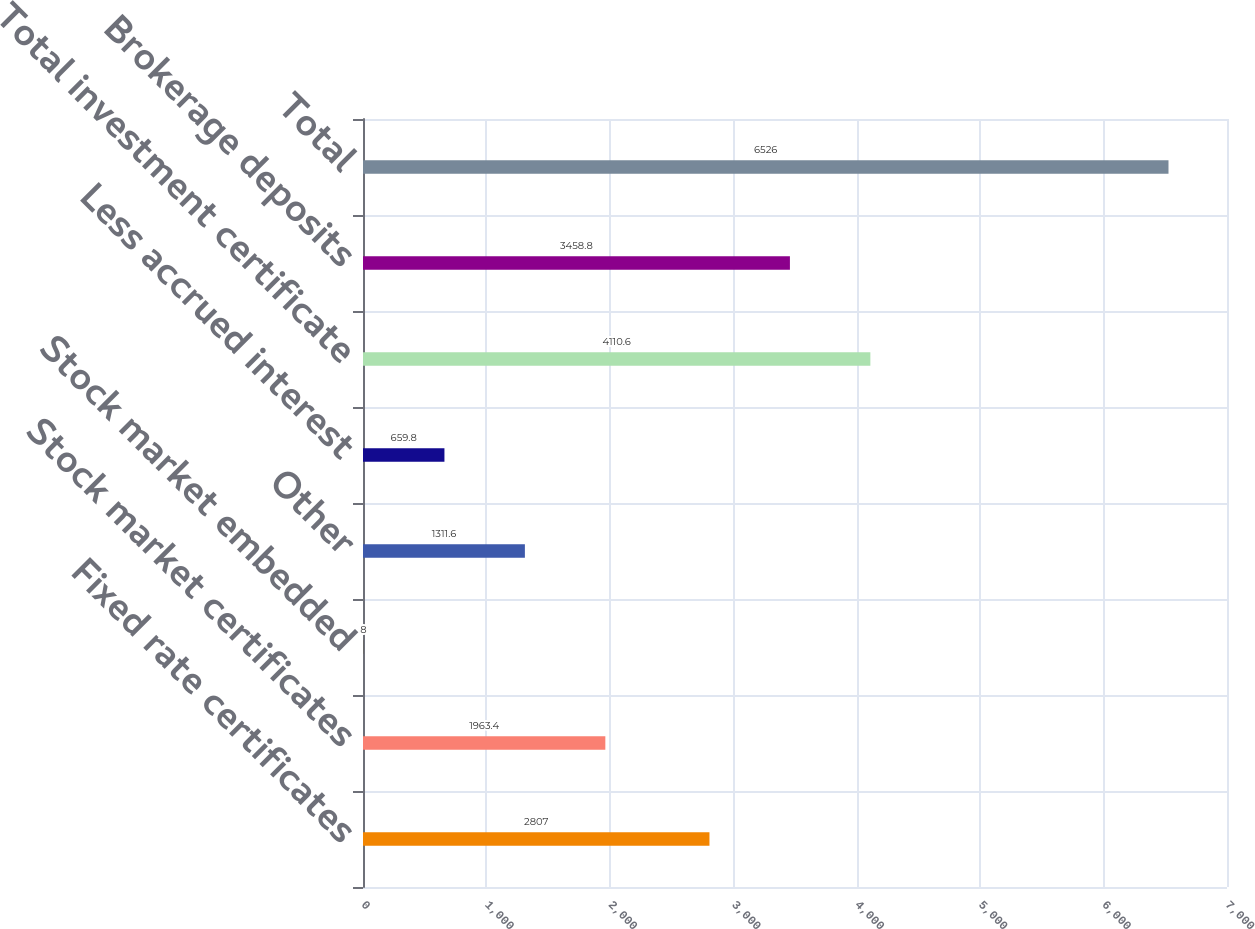Convert chart to OTSL. <chart><loc_0><loc_0><loc_500><loc_500><bar_chart><fcel>Fixed rate certificates<fcel>Stock market certificates<fcel>Stock market embedded<fcel>Other<fcel>Less accrued interest<fcel>Total investment certificate<fcel>Brokerage deposits<fcel>Total<nl><fcel>2807<fcel>1963.4<fcel>8<fcel>1311.6<fcel>659.8<fcel>4110.6<fcel>3458.8<fcel>6526<nl></chart> 